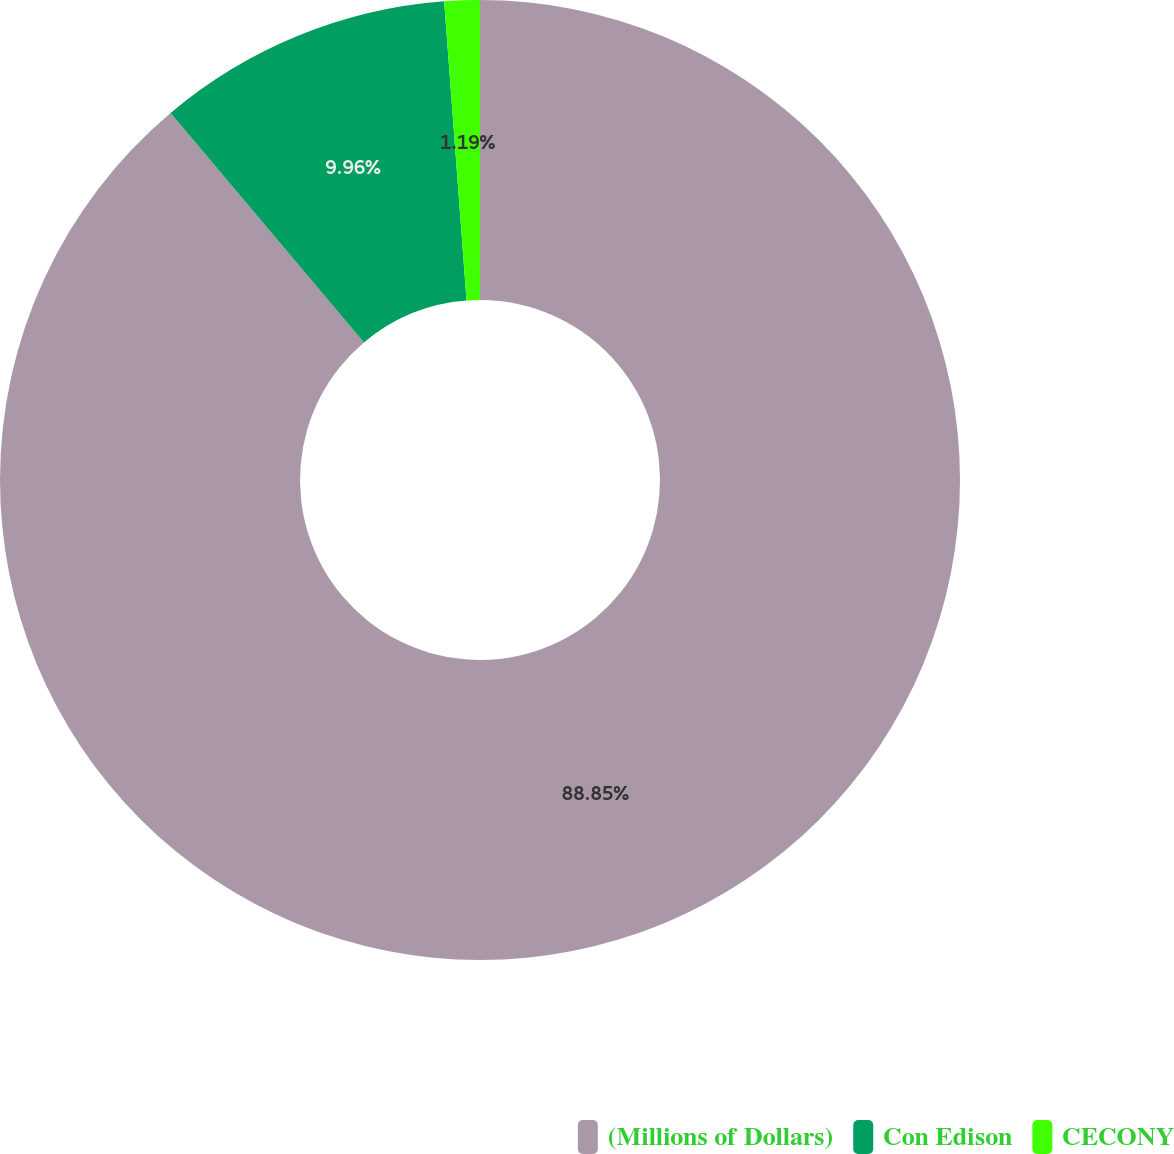Convert chart. <chart><loc_0><loc_0><loc_500><loc_500><pie_chart><fcel>(Millions of Dollars)<fcel>Con Edison<fcel>CECONY<nl><fcel>88.85%<fcel>9.96%<fcel>1.19%<nl></chart> 